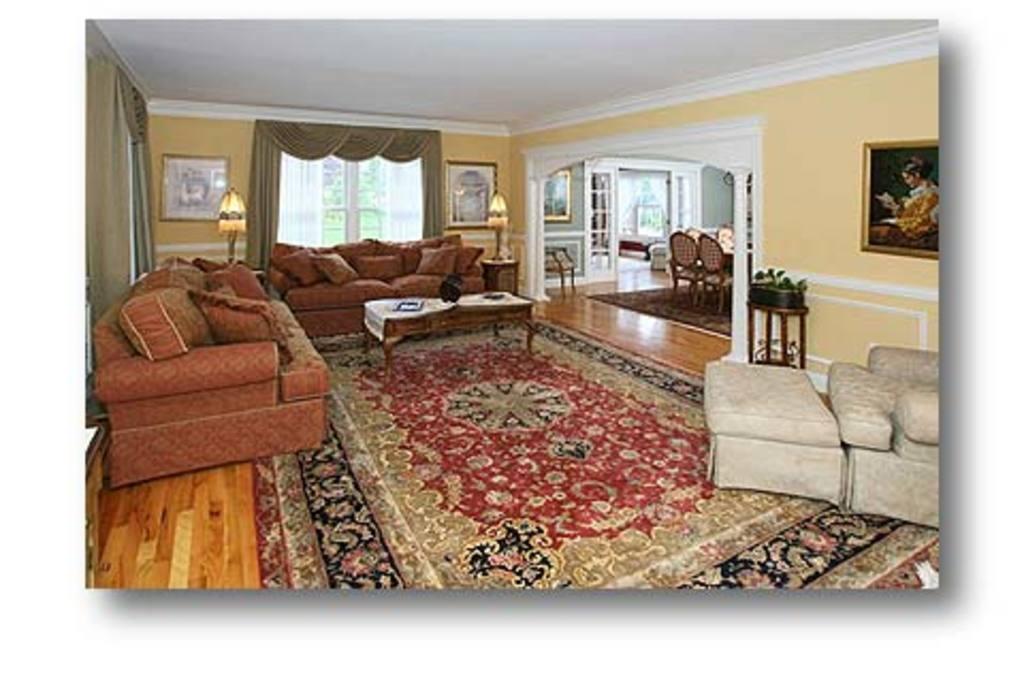Please provide a concise description of this image. This picture is a photograph of an inside view of a room. In the room there are couches and tables. There is carpet on the floor. There are table lamps on the table. On the other side of the room there is dining table and chairs. There is a houseplant to one of the corner of the image. There are picture frames hanging on the wall. In the background there are windows, curtains and wall. 